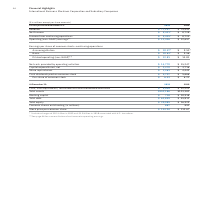According to International Business Machines's financial document, What does Net Income include? Includes charges of $0.1 billion in 2019 and $2.0 billion in 2018 associated with U.S. tax reform.. The document states: "* Includes charges of $0.1 billion in 2019 and $2.0 billion in 2018 associated with U.S. tax reform...." Also, What was the Operating (non-GAAP) earnings in 2019? According to the financial document, 11,436 (in millions). The relevant text states: "Operating (non-GAAP) earnings** $ 11,436 $ 12,657..." Also, What is the Basic earnings per share in 2019? According to the financial document, 10.63. The relevant text states: "Basic $ 10.63* $ 9.56*..." Also, can you calculate: What is the increase / (decrease) in revenue from 2018 to 2019? Based on the calculation: 77,147 - 79,591, the result is -2444 (in millions). This is based on the information: "Revenue $ 77,147 $ 79,591 Revenue $ 77,147 $ 79,591..." The key data points involved are: 77,147, 79,591. Also, can you calculate: What are the total assets increase / (decrease) from 2018 to 2019? Based on the calculation: 152,186 - 123,382, the result is 28804 (in millions). This is based on the information: "Total assets $152,186 $123,382 Total assets $152,186 $123,382..." The key data points involved are: 123,382, 152,186. Also, can you calculate: What is the Debt to Capital Ratio in 2019? To answer this question, I need to perform calculations using the financial data. The calculation is: 62,899 / (62,899 + 45,812), which equals 57.86 (percentage). This is based on the information: "Total debt $ 62,899 $ 45,812 Total debt $ 62,899 $ 45,812..." The key data points involved are: 45,812, 62,899. 